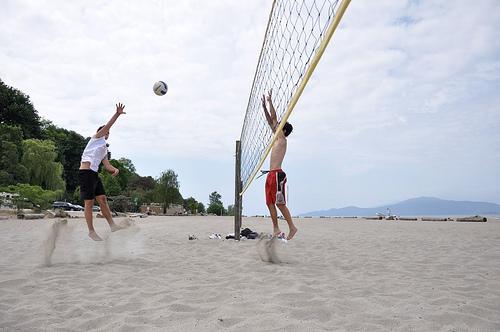What are these two people playing?
Give a very brief answer. Volleyball. Are the men jumping in the air?
Give a very brief answer. Yes. Where are they playing?
Give a very brief answer. Beach. 